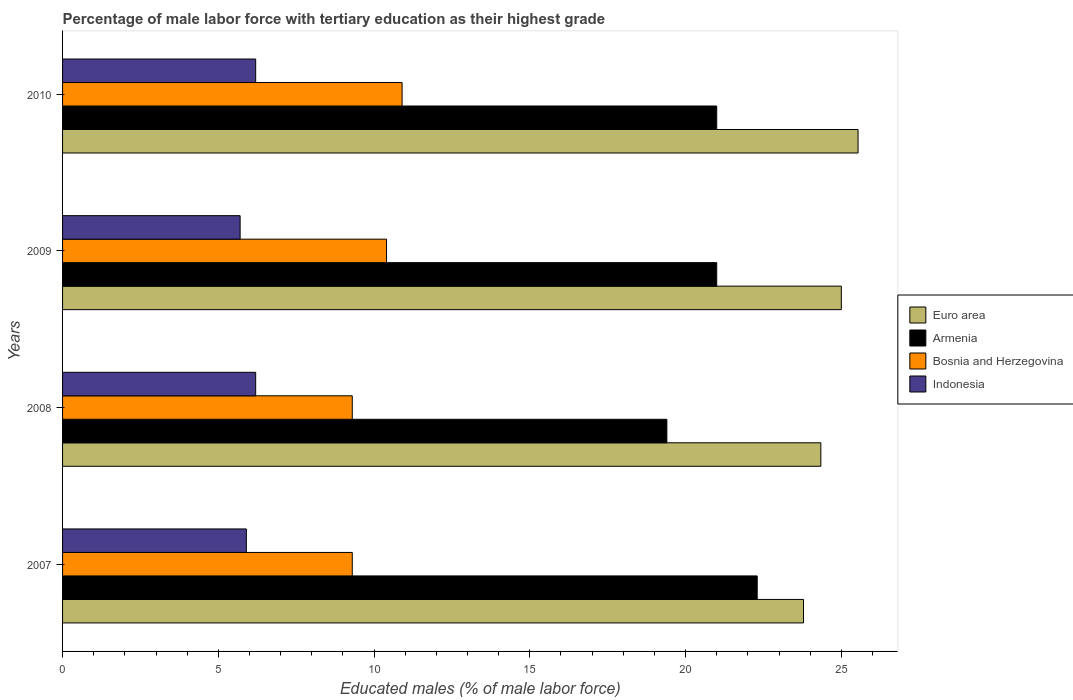How many different coloured bars are there?
Your response must be concise. 4. Are the number of bars per tick equal to the number of legend labels?
Your response must be concise. Yes. Are the number of bars on each tick of the Y-axis equal?
Ensure brevity in your answer.  Yes. How many bars are there on the 4th tick from the top?
Offer a terse response. 4. What is the label of the 1st group of bars from the top?
Give a very brief answer. 2010. In how many cases, is the number of bars for a given year not equal to the number of legend labels?
Ensure brevity in your answer.  0. What is the percentage of male labor force with tertiary education in Bosnia and Herzegovina in 2008?
Your response must be concise. 9.3. Across all years, what is the maximum percentage of male labor force with tertiary education in Bosnia and Herzegovina?
Keep it short and to the point. 10.9. Across all years, what is the minimum percentage of male labor force with tertiary education in Armenia?
Provide a succinct answer. 19.4. In which year was the percentage of male labor force with tertiary education in Bosnia and Herzegovina maximum?
Provide a succinct answer. 2010. In which year was the percentage of male labor force with tertiary education in Euro area minimum?
Offer a terse response. 2007. What is the total percentage of male labor force with tertiary education in Euro area in the graph?
Offer a terse response. 98.67. What is the difference between the percentage of male labor force with tertiary education in Euro area in 2007 and that in 2009?
Provide a succinct answer. -1.21. What is the difference between the percentage of male labor force with tertiary education in Bosnia and Herzegovina in 2010 and the percentage of male labor force with tertiary education in Armenia in 2008?
Make the answer very short. -8.5. What is the average percentage of male labor force with tertiary education in Indonesia per year?
Offer a very short reply. 6. In the year 2008, what is the difference between the percentage of male labor force with tertiary education in Bosnia and Herzegovina and percentage of male labor force with tertiary education in Armenia?
Provide a short and direct response. -10.1. In how many years, is the percentage of male labor force with tertiary education in Euro area greater than 7 %?
Keep it short and to the point. 4. What is the ratio of the percentage of male labor force with tertiary education in Bosnia and Herzegovina in 2007 to that in 2009?
Keep it short and to the point. 0.89. Is the difference between the percentage of male labor force with tertiary education in Bosnia and Herzegovina in 2007 and 2009 greater than the difference between the percentage of male labor force with tertiary education in Armenia in 2007 and 2009?
Your answer should be very brief. No. What is the difference between the highest and the second highest percentage of male labor force with tertiary education in Euro area?
Provide a succinct answer. 0.54. What is the difference between the highest and the lowest percentage of male labor force with tertiary education in Euro area?
Offer a very short reply. 1.75. In how many years, is the percentage of male labor force with tertiary education in Armenia greater than the average percentage of male labor force with tertiary education in Armenia taken over all years?
Your answer should be compact. 3. Is it the case that in every year, the sum of the percentage of male labor force with tertiary education in Armenia and percentage of male labor force with tertiary education in Indonesia is greater than the sum of percentage of male labor force with tertiary education in Bosnia and Herzegovina and percentage of male labor force with tertiary education in Euro area?
Your answer should be very brief. No. What does the 3rd bar from the top in 2008 represents?
Offer a very short reply. Armenia. What does the 1st bar from the bottom in 2007 represents?
Provide a succinct answer. Euro area. Is it the case that in every year, the sum of the percentage of male labor force with tertiary education in Indonesia and percentage of male labor force with tertiary education in Euro area is greater than the percentage of male labor force with tertiary education in Bosnia and Herzegovina?
Your answer should be very brief. Yes. How many bars are there?
Your response must be concise. 16. What is the difference between two consecutive major ticks on the X-axis?
Offer a very short reply. 5. Are the values on the major ticks of X-axis written in scientific E-notation?
Make the answer very short. No. Does the graph contain any zero values?
Ensure brevity in your answer.  No. Does the graph contain grids?
Ensure brevity in your answer.  No. Where does the legend appear in the graph?
Keep it short and to the point. Center right. What is the title of the graph?
Your answer should be compact. Percentage of male labor force with tertiary education as their highest grade. Does "New Caledonia" appear as one of the legend labels in the graph?
Your answer should be compact. No. What is the label or title of the X-axis?
Your response must be concise. Educated males (% of male labor force). What is the label or title of the Y-axis?
Ensure brevity in your answer.  Years. What is the Educated males (% of male labor force) in Euro area in 2007?
Ensure brevity in your answer.  23.79. What is the Educated males (% of male labor force) of Armenia in 2007?
Provide a succinct answer. 22.3. What is the Educated males (% of male labor force) in Bosnia and Herzegovina in 2007?
Provide a succinct answer. 9.3. What is the Educated males (% of male labor force) of Indonesia in 2007?
Give a very brief answer. 5.9. What is the Educated males (% of male labor force) in Euro area in 2008?
Your response must be concise. 24.34. What is the Educated males (% of male labor force) in Armenia in 2008?
Keep it short and to the point. 19.4. What is the Educated males (% of male labor force) in Bosnia and Herzegovina in 2008?
Offer a very short reply. 9.3. What is the Educated males (% of male labor force) of Indonesia in 2008?
Your response must be concise. 6.2. What is the Educated males (% of male labor force) in Euro area in 2009?
Ensure brevity in your answer.  25. What is the Educated males (% of male labor force) of Bosnia and Herzegovina in 2009?
Make the answer very short. 10.4. What is the Educated males (% of male labor force) in Indonesia in 2009?
Offer a terse response. 5.7. What is the Educated males (% of male labor force) in Euro area in 2010?
Ensure brevity in your answer.  25.54. What is the Educated males (% of male labor force) of Armenia in 2010?
Your answer should be very brief. 21. What is the Educated males (% of male labor force) in Bosnia and Herzegovina in 2010?
Your answer should be compact. 10.9. What is the Educated males (% of male labor force) in Indonesia in 2010?
Ensure brevity in your answer.  6.2. Across all years, what is the maximum Educated males (% of male labor force) in Euro area?
Your answer should be very brief. 25.54. Across all years, what is the maximum Educated males (% of male labor force) of Armenia?
Provide a succinct answer. 22.3. Across all years, what is the maximum Educated males (% of male labor force) in Bosnia and Herzegovina?
Your answer should be compact. 10.9. Across all years, what is the maximum Educated males (% of male labor force) of Indonesia?
Keep it short and to the point. 6.2. Across all years, what is the minimum Educated males (% of male labor force) in Euro area?
Provide a succinct answer. 23.79. Across all years, what is the minimum Educated males (% of male labor force) of Armenia?
Provide a short and direct response. 19.4. Across all years, what is the minimum Educated males (% of male labor force) of Bosnia and Herzegovina?
Offer a very short reply. 9.3. Across all years, what is the minimum Educated males (% of male labor force) of Indonesia?
Keep it short and to the point. 5.7. What is the total Educated males (% of male labor force) in Euro area in the graph?
Your response must be concise. 98.67. What is the total Educated males (% of male labor force) of Armenia in the graph?
Your answer should be very brief. 83.7. What is the total Educated males (% of male labor force) in Bosnia and Herzegovina in the graph?
Give a very brief answer. 39.9. What is the difference between the Educated males (% of male labor force) in Euro area in 2007 and that in 2008?
Provide a short and direct response. -0.56. What is the difference between the Educated males (% of male labor force) of Bosnia and Herzegovina in 2007 and that in 2008?
Give a very brief answer. 0. What is the difference between the Educated males (% of male labor force) of Euro area in 2007 and that in 2009?
Keep it short and to the point. -1.21. What is the difference between the Educated males (% of male labor force) in Armenia in 2007 and that in 2009?
Give a very brief answer. 1.3. What is the difference between the Educated males (% of male labor force) of Bosnia and Herzegovina in 2007 and that in 2009?
Your response must be concise. -1.1. What is the difference between the Educated males (% of male labor force) of Euro area in 2007 and that in 2010?
Your answer should be very brief. -1.75. What is the difference between the Educated males (% of male labor force) of Bosnia and Herzegovina in 2007 and that in 2010?
Provide a short and direct response. -1.6. What is the difference between the Educated males (% of male labor force) of Indonesia in 2007 and that in 2010?
Your response must be concise. -0.3. What is the difference between the Educated males (% of male labor force) of Euro area in 2008 and that in 2009?
Provide a short and direct response. -0.66. What is the difference between the Educated males (% of male labor force) of Bosnia and Herzegovina in 2008 and that in 2009?
Give a very brief answer. -1.1. What is the difference between the Educated males (% of male labor force) in Indonesia in 2008 and that in 2009?
Your answer should be very brief. 0.5. What is the difference between the Educated males (% of male labor force) of Euro area in 2008 and that in 2010?
Offer a very short reply. -1.19. What is the difference between the Educated males (% of male labor force) of Indonesia in 2008 and that in 2010?
Your response must be concise. 0. What is the difference between the Educated males (% of male labor force) in Euro area in 2009 and that in 2010?
Offer a terse response. -0.54. What is the difference between the Educated males (% of male labor force) of Armenia in 2009 and that in 2010?
Ensure brevity in your answer.  0. What is the difference between the Educated males (% of male labor force) of Bosnia and Herzegovina in 2009 and that in 2010?
Ensure brevity in your answer.  -0.5. What is the difference between the Educated males (% of male labor force) in Indonesia in 2009 and that in 2010?
Give a very brief answer. -0.5. What is the difference between the Educated males (% of male labor force) in Euro area in 2007 and the Educated males (% of male labor force) in Armenia in 2008?
Ensure brevity in your answer.  4.39. What is the difference between the Educated males (% of male labor force) in Euro area in 2007 and the Educated males (% of male labor force) in Bosnia and Herzegovina in 2008?
Offer a terse response. 14.49. What is the difference between the Educated males (% of male labor force) in Euro area in 2007 and the Educated males (% of male labor force) in Indonesia in 2008?
Ensure brevity in your answer.  17.59. What is the difference between the Educated males (% of male labor force) of Euro area in 2007 and the Educated males (% of male labor force) of Armenia in 2009?
Keep it short and to the point. 2.79. What is the difference between the Educated males (% of male labor force) in Euro area in 2007 and the Educated males (% of male labor force) in Bosnia and Herzegovina in 2009?
Offer a terse response. 13.39. What is the difference between the Educated males (% of male labor force) of Euro area in 2007 and the Educated males (% of male labor force) of Indonesia in 2009?
Provide a short and direct response. 18.09. What is the difference between the Educated males (% of male labor force) of Armenia in 2007 and the Educated males (% of male labor force) of Indonesia in 2009?
Your answer should be very brief. 16.6. What is the difference between the Educated males (% of male labor force) of Bosnia and Herzegovina in 2007 and the Educated males (% of male labor force) of Indonesia in 2009?
Ensure brevity in your answer.  3.6. What is the difference between the Educated males (% of male labor force) of Euro area in 2007 and the Educated males (% of male labor force) of Armenia in 2010?
Offer a terse response. 2.79. What is the difference between the Educated males (% of male labor force) in Euro area in 2007 and the Educated males (% of male labor force) in Bosnia and Herzegovina in 2010?
Your response must be concise. 12.89. What is the difference between the Educated males (% of male labor force) of Euro area in 2007 and the Educated males (% of male labor force) of Indonesia in 2010?
Offer a very short reply. 17.59. What is the difference between the Educated males (% of male labor force) in Bosnia and Herzegovina in 2007 and the Educated males (% of male labor force) in Indonesia in 2010?
Ensure brevity in your answer.  3.1. What is the difference between the Educated males (% of male labor force) of Euro area in 2008 and the Educated males (% of male labor force) of Armenia in 2009?
Your answer should be compact. 3.34. What is the difference between the Educated males (% of male labor force) of Euro area in 2008 and the Educated males (% of male labor force) of Bosnia and Herzegovina in 2009?
Provide a short and direct response. 13.94. What is the difference between the Educated males (% of male labor force) of Euro area in 2008 and the Educated males (% of male labor force) of Indonesia in 2009?
Offer a terse response. 18.64. What is the difference between the Educated males (% of male labor force) of Armenia in 2008 and the Educated males (% of male labor force) of Bosnia and Herzegovina in 2009?
Your answer should be very brief. 9. What is the difference between the Educated males (% of male labor force) in Armenia in 2008 and the Educated males (% of male labor force) in Indonesia in 2009?
Your response must be concise. 13.7. What is the difference between the Educated males (% of male labor force) in Euro area in 2008 and the Educated males (% of male labor force) in Armenia in 2010?
Your response must be concise. 3.34. What is the difference between the Educated males (% of male labor force) of Euro area in 2008 and the Educated males (% of male labor force) of Bosnia and Herzegovina in 2010?
Your response must be concise. 13.44. What is the difference between the Educated males (% of male labor force) of Euro area in 2008 and the Educated males (% of male labor force) of Indonesia in 2010?
Your answer should be compact. 18.14. What is the difference between the Educated males (% of male labor force) in Armenia in 2008 and the Educated males (% of male labor force) in Bosnia and Herzegovina in 2010?
Make the answer very short. 8.5. What is the difference between the Educated males (% of male labor force) in Bosnia and Herzegovina in 2008 and the Educated males (% of male labor force) in Indonesia in 2010?
Ensure brevity in your answer.  3.1. What is the difference between the Educated males (% of male labor force) in Euro area in 2009 and the Educated males (% of male labor force) in Armenia in 2010?
Ensure brevity in your answer.  4. What is the difference between the Educated males (% of male labor force) in Euro area in 2009 and the Educated males (% of male labor force) in Bosnia and Herzegovina in 2010?
Offer a terse response. 14.1. What is the difference between the Educated males (% of male labor force) in Euro area in 2009 and the Educated males (% of male labor force) in Indonesia in 2010?
Offer a terse response. 18.8. What is the average Educated males (% of male labor force) of Euro area per year?
Offer a very short reply. 24.67. What is the average Educated males (% of male labor force) in Armenia per year?
Offer a very short reply. 20.93. What is the average Educated males (% of male labor force) in Bosnia and Herzegovina per year?
Your response must be concise. 9.97. In the year 2007, what is the difference between the Educated males (% of male labor force) of Euro area and Educated males (% of male labor force) of Armenia?
Your answer should be very brief. 1.49. In the year 2007, what is the difference between the Educated males (% of male labor force) in Euro area and Educated males (% of male labor force) in Bosnia and Herzegovina?
Your answer should be very brief. 14.49. In the year 2007, what is the difference between the Educated males (% of male labor force) in Euro area and Educated males (% of male labor force) in Indonesia?
Your answer should be very brief. 17.89. In the year 2007, what is the difference between the Educated males (% of male labor force) of Armenia and Educated males (% of male labor force) of Bosnia and Herzegovina?
Give a very brief answer. 13. In the year 2007, what is the difference between the Educated males (% of male labor force) in Armenia and Educated males (% of male labor force) in Indonesia?
Your answer should be compact. 16.4. In the year 2007, what is the difference between the Educated males (% of male labor force) of Bosnia and Herzegovina and Educated males (% of male labor force) of Indonesia?
Ensure brevity in your answer.  3.4. In the year 2008, what is the difference between the Educated males (% of male labor force) in Euro area and Educated males (% of male labor force) in Armenia?
Make the answer very short. 4.94. In the year 2008, what is the difference between the Educated males (% of male labor force) in Euro area and Educated males (% of male labor force) in Bosnia and Herzegovina?
Your answer should be compact. 15.04. In the year 2008, what is the difference between the Educated males (% of male labor force) in Euro area and Educated males (% of male labor force) in Indonesia?
Offer a very short reply. 18.14. In the year 2008, what is the difference between the Educated males (% of male labor force) in Armenia and Educated males (% of male labor force) in Indonesia?
Make the answer very short. 13.2. In the year 2008, what is the difference between the Educated males (% of male labor force) of Bosnia and Herzegovina and Educated males (% of male labor force) of Indonesia?
Offer a very short reply. 3.1. In the year 2009, what is the difference between the Educated males (% of male labor force) in Euro area and Educated males (% of male labor force) in Armenia?
Provide a short and direct response. 4. In the year 2009, what is the difference between the Educated males (% of male labor force) in Euro area and Educated males (% of male labor force) in Bosnia and Herzegovina?
Offer a very short reply. 14.6. In the year 2009, what is the difference between the Educated males (% of male labor force) of Euro area and Educated males (% of male labor force) of Indonesia?
Offer a very short reply. 19.3. In the year 2009, what is the difference between the Educated males (% of male labor force) of Armenia and Educated males (% of male labor force) of Indonesia?
Give a very brief answer. 15.3. In the year 2009, what is the difference between the Educated males (% of male labor force) of Bosnia and Herzegovina and Educated males (% of male labor force) of Indonesia?
Your answer should be very brief. 4.7. In the year 2010, what is the difference between the Educated males (% of male labor force) in Euro area and Educated males (% of male labor force) in Armenia?
Ensure brevity in your answer.  4.54. In the year 2010, what is the difference between the Educated males (% of male labor force) of Euro area and Educated males (% of male labor force) of Bosnia and Herzegovina?
Your answer should be very brief. 14.64. In the year 2010, what is the difference between the Educated males (% of male labor force) in Euro area and Educated males (% of male labor force) in Indonesia?
Your answer should be compact. 19.34. In the year 2010, what is the difference between the Educated males (% of male labor force) of Bosnia and Herzegovina and Educated males (% of male labor force) of Indonesia?
Provide a short and direct response. 4.7. What is the ratio of the Educated males (% of male labor force) of Euro area in 2007 to that in 2008?
Your response must be concise. 0.98. What is the ratio of the Educated males (% of male labor force) in Armenia in 2007 to that in 2008?
Your response must be concise. 1.15. What is the ratio of the Educated males (% of male labor force) in Bosnia and Herzegovina in 2007 to that in 2008?
Your answer should be very brief. 1. What is the ratio of the Educated males (% of male labor force) of Indonesia in 2007 to that in 2008?
Keep it short and to the point. 0.95. What is the ratio of the Educated males (% of male labor force) in Euro area in 2007 to that in 2009?
Offer a very short reply. 0.95. What is the ratio of the Educated males (% of male labor force) in Armenia in 2007 to that in 2009?
Provide a short and direct response. 1.06. What is the ratio of the Educated males (% of male labor force) in Bosnia and Herzegovina in 2007 to that in 2009?
Provide a short and direct response. 0.89. What is the ratio of the Educated males (% of male labor force) in Indonesia in 2007 to that in 2009?
Your answer should be compact. 1.04. What is the ratio of the Educated males (% of male labor force) of Euro area in 2007 to that in 2010?
Ensure brevity in your answer.  0.93. What is the ratio of the Educated males (% of male labor force) in Armenia in 2007 to that in 2010?
Your response must be concise. 1.06. What is the ratio of the Educated males (% of male labor force) of Bosnia and Herzegovina in 2007 to that in 2010?
Your answer should be very brief. 0.85. What is the ratio of the Educated males (% of male labor force) in Indonesia in 2007 to that in 2010?
Offer a terse response. 0.95. What is the ratio of the Educated males (% of male labor force) in Euro area in 2008 to that in 2009?
Offer a terse response. 0.97. What is the ratio of the Educated males (% of male labor force) in Armenia in 2008 to that in 2009?
Your answer should be compact. 0.92. What is the ratio of the Educated males (% of male labor force) in Bosnia and Herzegovina in 2008 to that in 2009?
Provide a short and direct response. 0.89. What is the ratio of the Educated males (% of male labor force) of Indonesia in 2008 to that in 2009?
Your response must be concise. 1.09. What is the ratio of the Educated males (% of male labor force) of Euro area in 2008 to that in 2010?
Make the answer very short. 0.95. What is the ratio of the Educated males (% of male labor force) of Armenia in 2008 to that in 2010?
Keep it short and to the point. 0.92. What is the ratio of the Educated males (% of male labor force) in Bosnia and Herzegovina in 2008 to that in 2010?
Your answer should be compact. 0.85. What is the ratio of the Educated males (% of male labor force) in Euro area in 2009 to that in 2010?
Offer a very short reply. 0.98. What is the ratio of the Educated males (% of male labor force) in Bosnia and Herzegovina in 2009 to that in 2010?
Keep it short and to the point. 0.95. What is the ratio of the Educated males (% of male labor force) in Indonesia in 2009 to that in 2010?
Your response must be concise. 0.92. What is the difference between the highest and the second highest Educated males (% of male labor force) of Euro area?
Provide a short and direct response. 0.54. What is the difference between the highest and the lowest Educated males (% of male labor force) of Euro area?
Make the answer very short. 1.75. What is the difference between the highest and the lowest Educated males (% of male labor force) of Indonesia?
Offer a terse response. 0.5. 